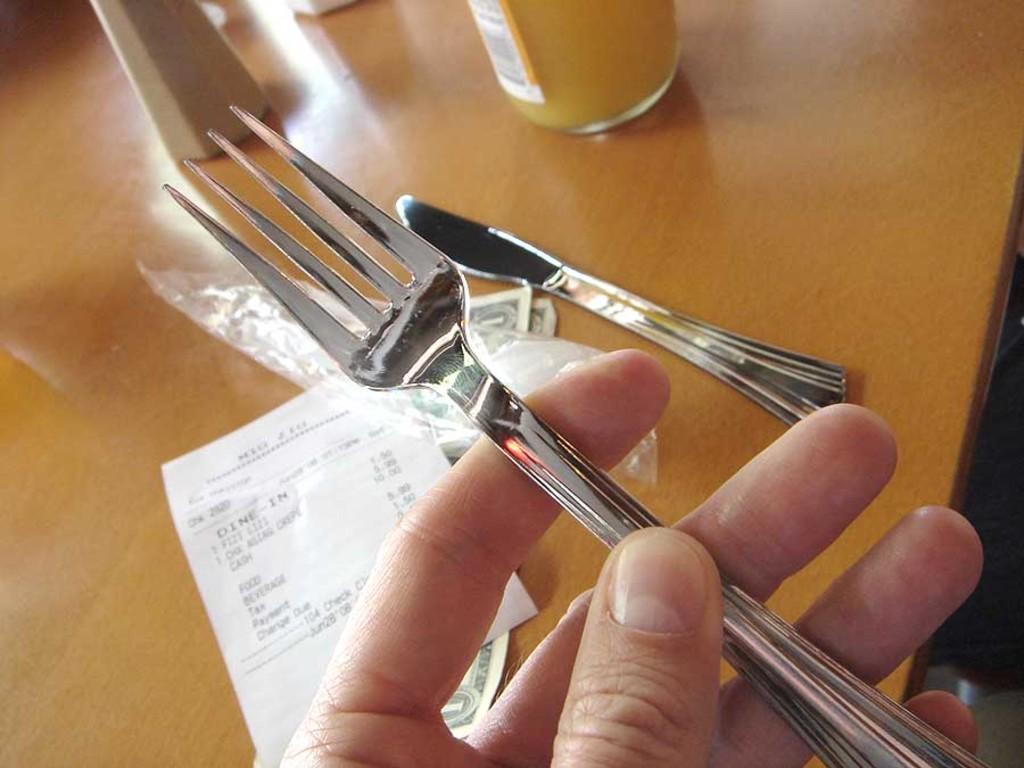How would you summarize this image in a sentence or two? In this image in the foreground there is one person who is holding a fork, and in the background there is one table. On the table there are some bottles, butter knife and some papers. 